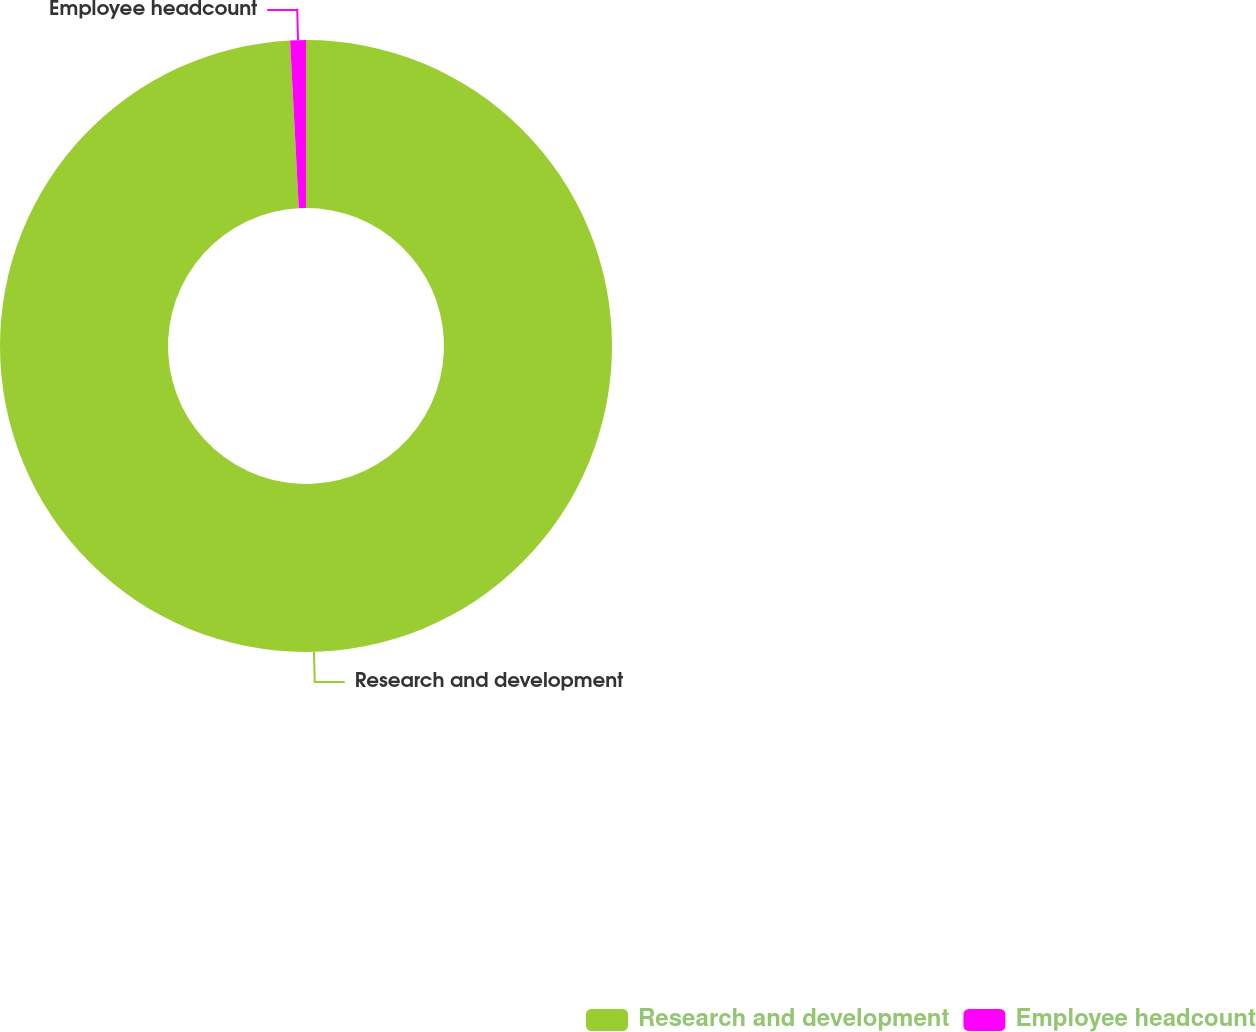Convert chart. <chart><loc_0><loc_0><loc_500><loc_500><pie_chart><fcel>Research and development<fcel>Employee headcount<nl><fcel>99.17%<fcel>0.83%<nl></chart> 